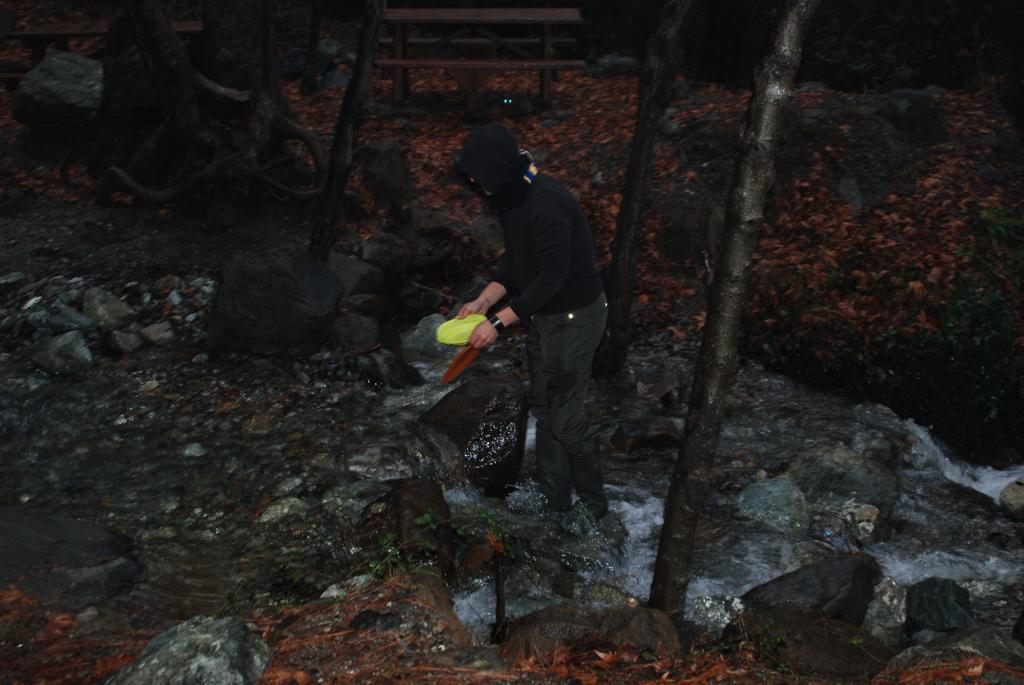Could you give a brief overview of what you see in this image? This picture few rocks on the ground and we see trees and water flowing and we see a man wore a cap on his head and holding a plastic bowl in his hand. 